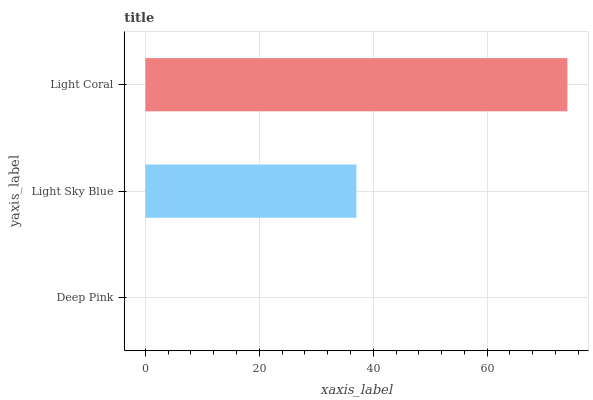Is Deep Pink the minimum?
Answer yes or no. Yes. Is Light Coral the maximum?
Answer yes or no. Yes. Is Light Sky Blue the minimum?
Answer yes or no. No. Is Light Sky Blue the maximum?
Answer yes or no. No. Is Light Sky Blue greater than Deep Pink?
Answer yes or no. Yes. Is Deep Pink less than Light Sky Blue?
Answer yes or no. Yes. Is Deep Pink greater than Light Sky Blue?
Answer yes or no. No. Is Light Sky Blue less than Deep Pink?
Answer yes or no. No. Is Light Sky Blue the high median?
Answer yes or no. Yes. Is Light Sky Blue the low median?
Answer yes or no. Yes. Is Light Coral the high median?
Answer yes or no. No. Is Deep Pink the low median?
Answer yes or no. No. 